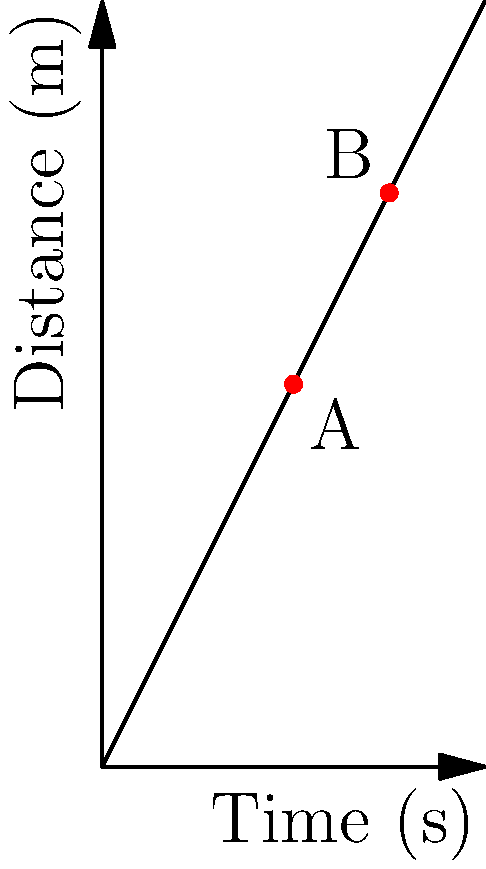In the distance-time graph shown, a car travels from point A to point B. If point A represents the car's position at 5 seconds and point B represents its position at 7.5 seconds, what is the average velocity of the car between these two points? To calculate the average velocity, we need to use the formula:

$$ v = \frac{\Delta d}{\Delta t} $$

Where $v$ is velocity, $\Delta d$ is change in distance, and $\Delta t$ is change in time.

Step 1: Determine the change in distance ($\Delta d$)
- Distance at point B: 15 m
- Distance at point A: 10 m
$\Delta d = 15 \text{ m} - 10 \text{ m} = 5 \text{ m}$

Step 2: Determine the change in time ($\Delta t$)
- Time at point B: 7.5 s
- Time at point A: 5 s
$\Delta t = 7.5 \text{ s} - 5 \text{ s} = 2.5 \text{ s}$

Step 3: Calculate the average velocity
$$ v = \frac{\Delta d}{\Delta t} = \frac{5 \text{ m}}{2.5 \text{ s}} = 2 \text{ m/s} $$

Therefore, the average velocity of the car between points A and B is 2 m/s.
Answer: 2 m/s 